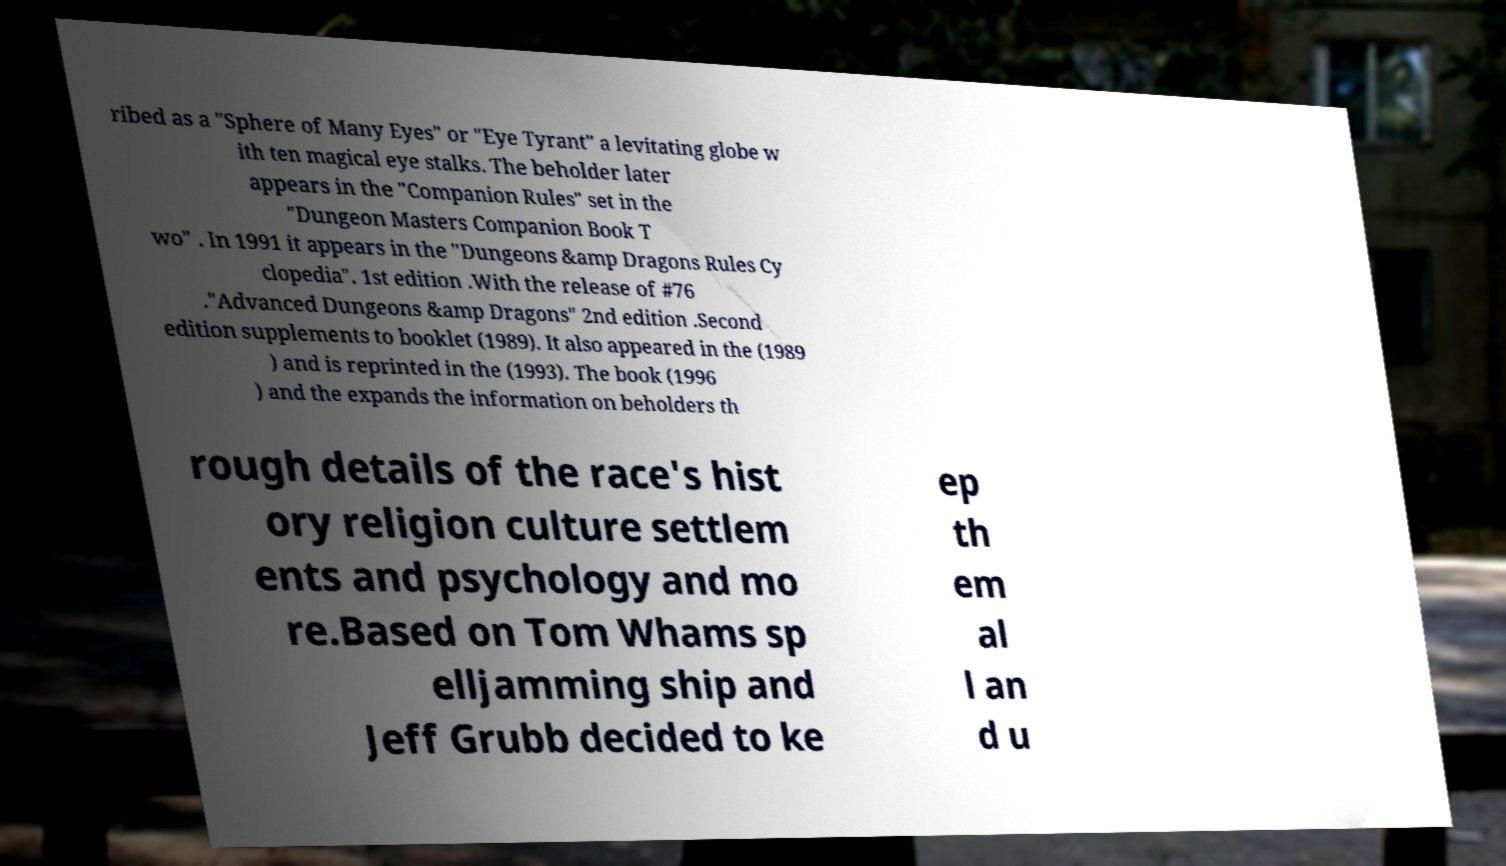I need the written content from this picture converted into text. Can you do that? ribed as a "Sphere of Many Eyes" or "Eye Tyrant" a levitating globe w ith ten magical eye stalks. The beholder later appears in the "Companion Rules" set in the "Dungeon Masters Companion Book T wo" . In 1991 it appears in the "Dungeons &amp Dragons Rules Cy clopedia". 1st edition .With the release of #76 ."Advanced Dungeons &amp Dragons" 2nd edition .Second edition supplements to booklet (1989). It also appeared in the (1989 ) and is reprinted in the (1993). The book (1996 ) and the expands the information on beholders th rough details of the race's hist ory religion culture settlem ents and psychology and mo re.Based on Tom Whams sp elljamming ship and Jeff Grubb decided to ke ep th em al l an d u 